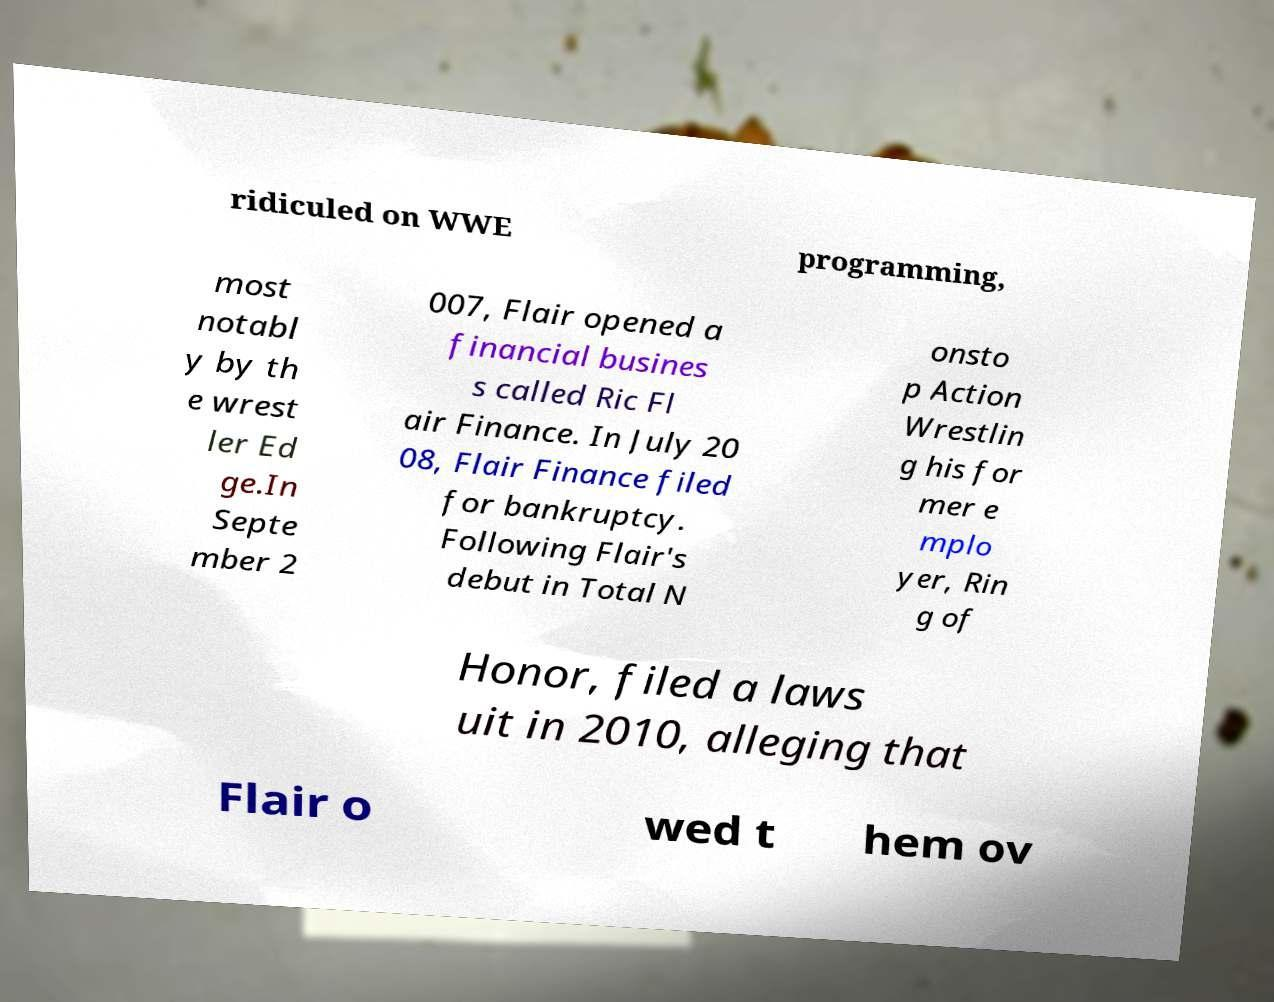What messages or text are displayed in this image? I need them in a readable, typed format. ridiculed on WWE programming, most notabl y by th e wrest ler Ed ge.In Septe mber 2 007, Flair opened a financial busines s called Ric Fl air Finance. In July 20 08, Flair Finance filed for bankruptcy. Following Flair's debut in Total N onsto p Action Wrestlin g his for mer e mplo yer, Rin g of Honor, filed a laws uit in 2010, alleging that Flair o wed t hem ov 